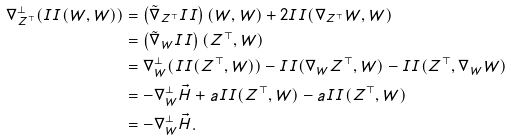<formula> <loc_0><loc_0><loc_500><loc_500>\nabla _ { Z ^ { \top } } ^ { \perp } ( I I ( W , W ) ) & = \left ( \tilde { \nabla } _ { Z ^ { \top } } I I \right ) ( W , W ) + 2 I I ( \nabla _ { Z ^ { \top } } W , W ) \\ & = \left ( \tilde { \nabla } _ { W } I I \right ) ( Z ^ { \top } , W ) \\ & = \nabla _ { W } ^ { \perp } ( I I ( Z ^ { \top } , W ) ) - I I ( \nabla _ { W } Z ^ { \top } , W ) - I I ( Z ^ { \top } , \nabla _ { W } W ) \\ & = - \nabla _ { W } ^ { \perp } \vec { H } + a I I ( Z ^ { \top } , W ) - a I I ( Z ^ { \top } , W ) \\ & = - \nabla _ { W } ^ { \perp } \vec { H } .</formula> 